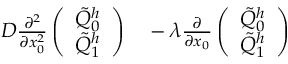Convert formula to latex. <formula><loc_0><loc_0><loc_500><loc_500>\begin{array} { r l } { D \frac { \partial ^ { 2 } } { \partial x _ { 0 } ^ { 2 } } \left ( \begin{array} { l } { \tilde { Q } _ { 0 } ^ { h } } \\ { \tilde { Q } _ { 1 } ^ { h } } \end{array} \right ) } & - \lambda \frac { \partial } { \partial x _ { 0 } } \left ( \begin{array} { l } { \tilde { Q } _ { 0 } ^ { h } } \\ { \tilde { Q } _ { 1 } ^ { h } } \end{array} \right ) } \end{array}</formula> 